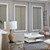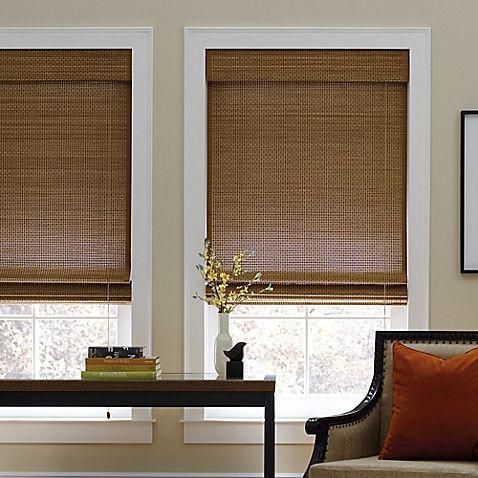The first image is the image on the left, the second image is the image on the right. Assess this claim about the two images: "There are exactly three shades in the left image.". Correct or not? Answer yes or no. Yes. 